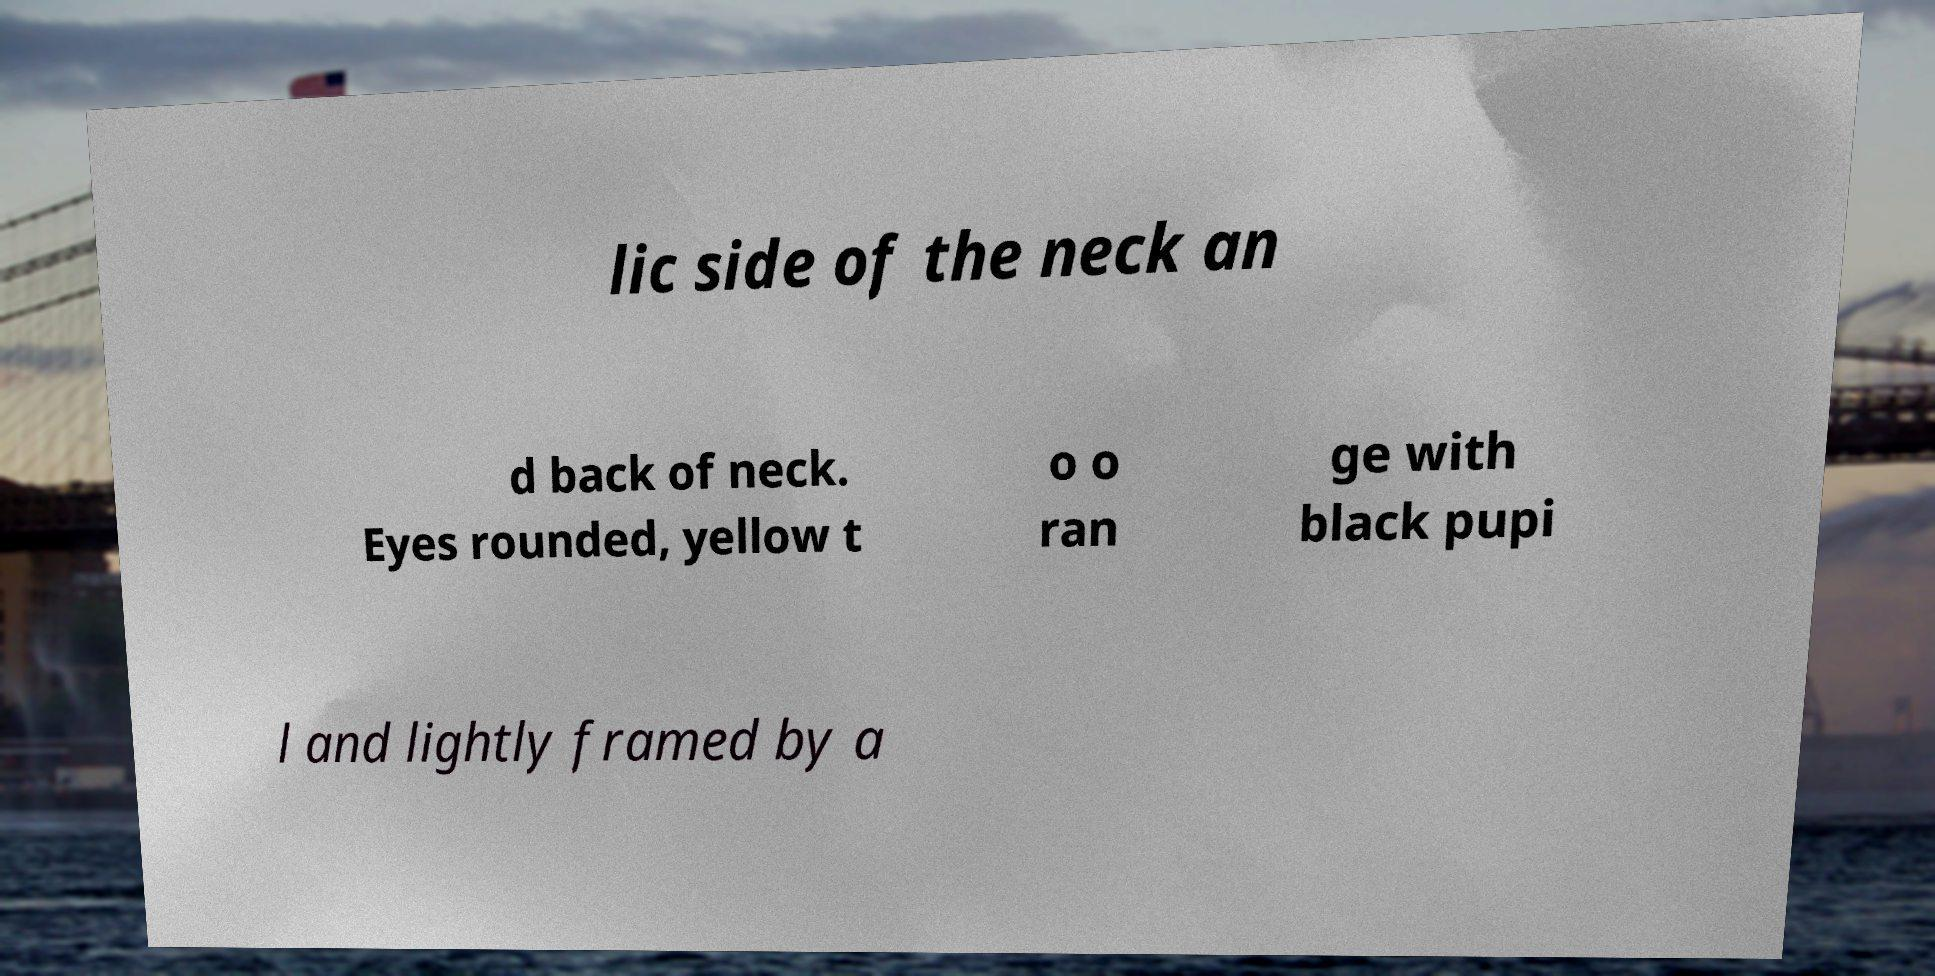What messages or text are displayed in this image? I need them in a readable, typed format. lic side of the neck an d back of neck. Eyes rounded, yellow t o o ran ge with black pupi l and lightly framed by a 